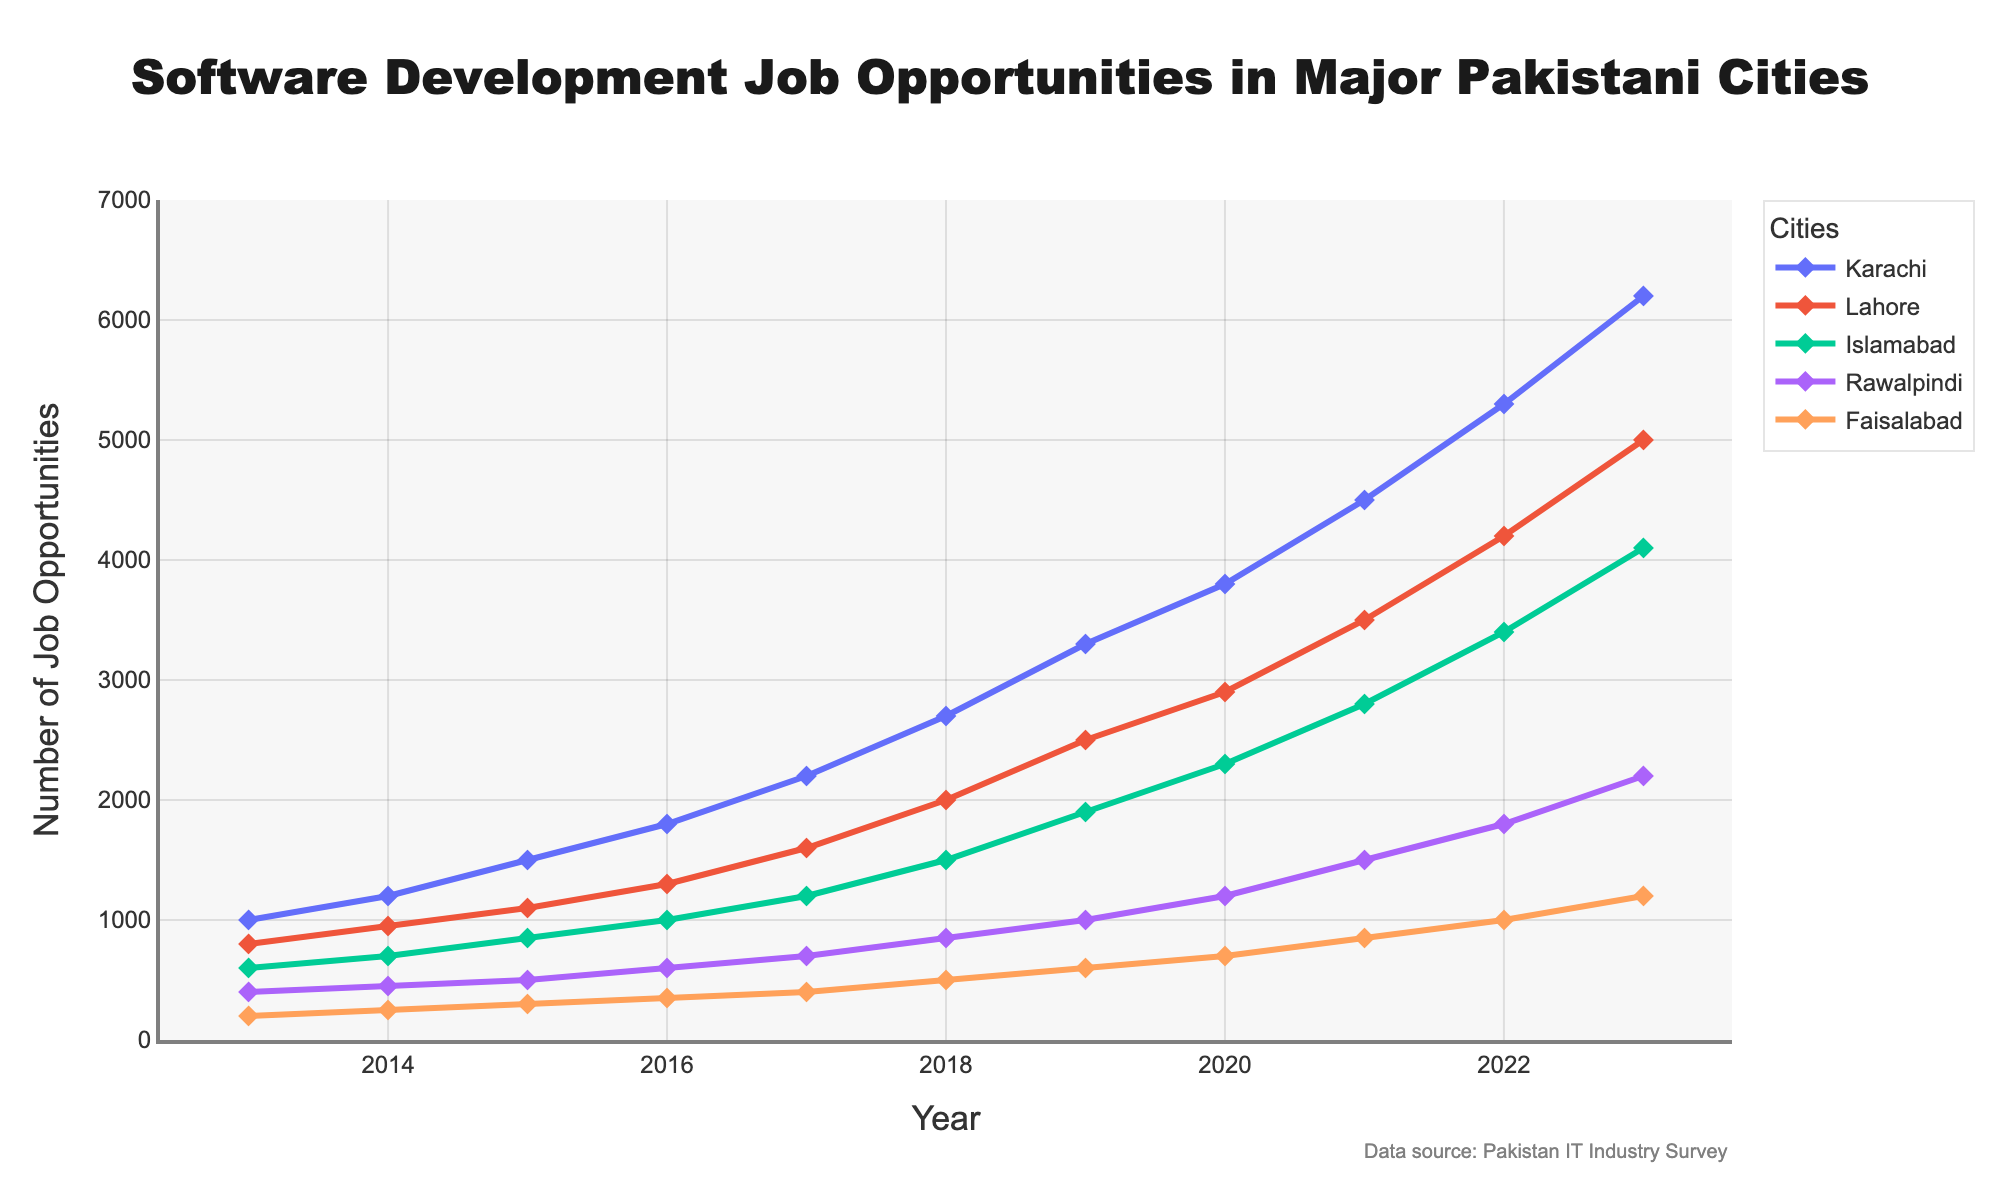What trend do you notice for software development job opportunities in Karachi over the past decade? To answer this, one needs to observe the line representing Karachi on the line chart. From 2013 to 2023, the data shows a steady increase in job opportunities, starting from 1000 in 2013 and rising to 6200 in 2023.
Answer: Steady increase Which city had the highest number of software development job opportunities in 2018? By looking at the values for each city in 2018, Karachi had 2700 opportunities, Lahore had 2000, Islamabad had 1500, Rawalpindi had 850, and Faisalabad had 500. Karachi had the highest number of opportunities.
Answer: Karachi Between Lahore and Islamabad, which city showed a greater increase in job opportunities from 2013 to 2023? Lahore increased from 800 in 2013 to 5000 in 2023, a total increase of 4200. Islamabad increased from 600 in 2013 to 4100 in 2023, a total increase of 3500. Lahore had a greater increase.
Answer: Lahore What is the combined number of job opportunities in Rawalpindi and Faisalabad in 2023? The value for Rawalpindi in 2023 is 2200 and for Faisalabad, it is 1200. The combined number is 2200 + 1200 = 3400.
Answer: 3400 How did the trend in job opportunities in Faisalabad change from 2017 to 2020? Looking at the value for Faisalabad, it increased from 400 in 2017 to 700 in 2020. This shows a gradual increase over these years.
Answer: Gradual increase Between which two consecutive years did Islamabad see the biggest jump in job opportunities? By examining the values year by year, the biggest jump for Islamabad appears between 2021 (2800) and 2022 (3400), a difference of 600.
Answer: 2021-2022 What is the average number of job opportunities in Karachi over the decade? Summing the values for Karachi from 2013 to 2023: 1000 + 1200 + 1500 + 1800 + 2200 + 2700 + 3300 + 3800 + 4500 + 5300 + 6200 = 33500. The average is 33500 ÷ 11 = 3045.
Answer: 3045 Which city had the least number of job opportunities throughout the entire period from 2013 to 2023? By looking at the data, Faisalabad consistently had the lowest number of job opportunities each year compared to other cities.
Answer: Faisalabad 